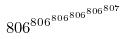Convert formula to latex. <formula><loc_0><loc_0><loc_500><loc_500>8 0 6 ^ { 8 0 6 ^ { 8 0 6 ^ { 8 0 6 ^ { 8 0 6 ^ { 8 0 7 } } } } }</formula> 